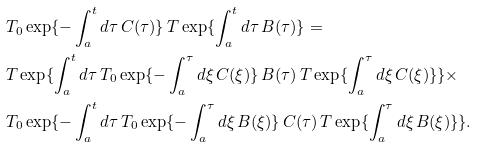Convert formula to latex. <formula><loc_0><loc_0><loc_500><loc_500>& { T } _ { 0 } \exp \{ - \int _ { a } ^ { t } d \tau \, { C } ( \tau ) \} \, { T } \exp \{ \int _ { a } ^ { t } d \tau \, { B } ( \tau ) \} = \\ & { T } \exp \{ \int _ { a } ^ { t } d \tau \, { T } _ { 0 } \exp \{ - \int _ { a } ^ { \tau } d \xi \, { C } ( \xi ) \} \, { B } ( \tau ) \, { T } \exp \{ \int _ { a } ^ { \tau } d \xi \, { C } ( \xi ) \} \} \times \\ & { T } _ { 0 } \exp \{ - \int _ { a } ^ { t } d \tau \, { T } _ { 0 } \exp \{ - \int _ { a } ^ { \tau } d \xi \, { B } ( \xi ) \} \, { C } ( \tau ) \, { T } \exp \{ \int _ { a } ^ { \tau } d \xi \, { B } ( \xi ) \} \} .</formula> 